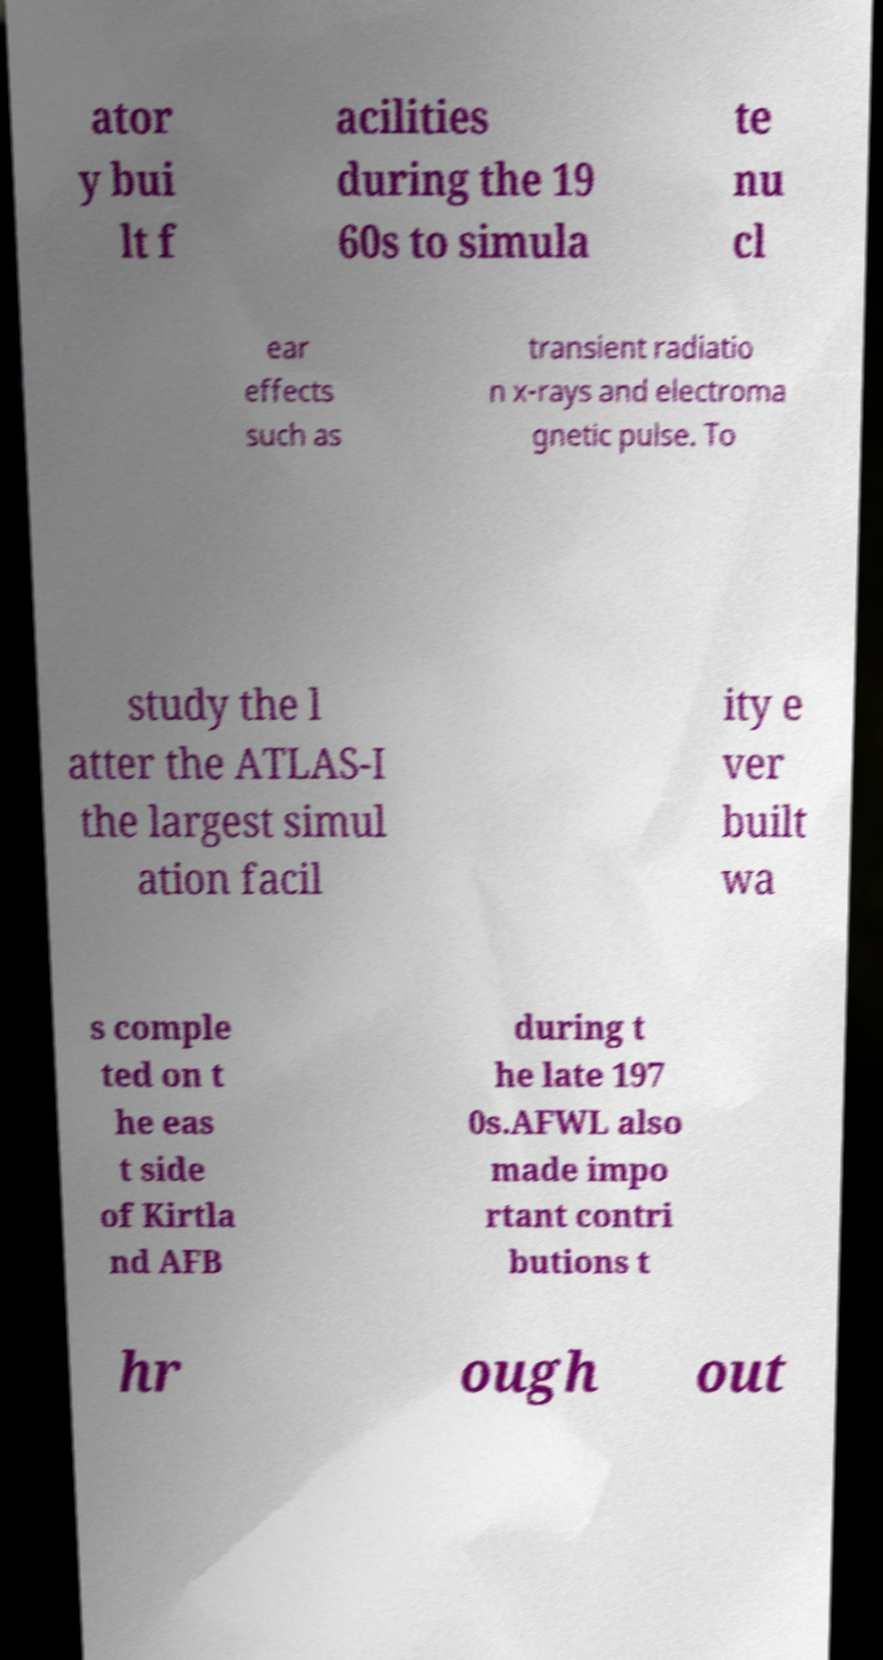Could you assist in decoding the text presented in this image and type it out clearly? ator y bui lt f acilities during the 19 60s to simula te nu cl ear effects such as transient radiatio n x-rays and electroma gnetic pulse. To study the l atter the ATLAS-I the largest simul ation facil ity e ver built wa s comple ted on t he eas t side of Kirtla nd AFB during t he late 197 0s.AFWL also made impo rtant contri butions t hr ough out 